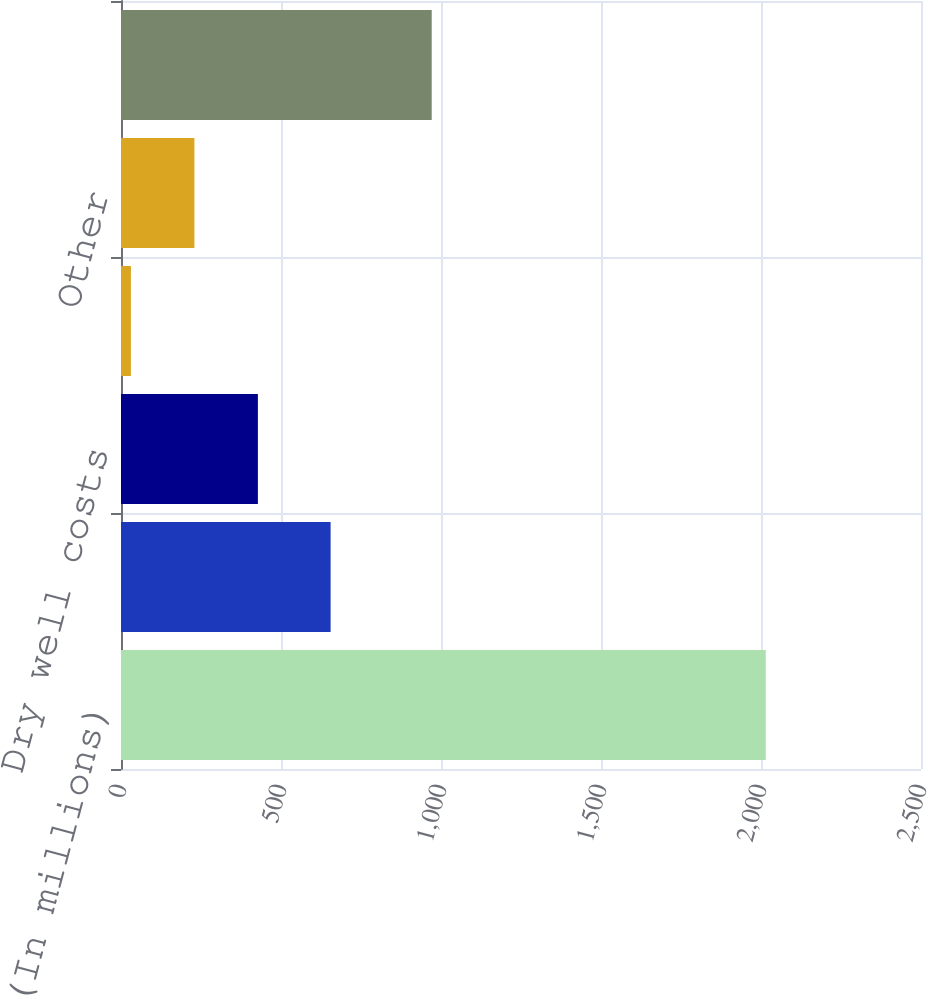<chart> <loc_0><loc_0><loc_500><loc_500><bar_chart><fcel>(In millions)<fcel>Unproved property impairments<fcel>Dry well costs<fcel>Geological and geophysical<fcel>Other<fcel>Total exploration expenses<nl><fcel>2015<fcel>655<fcel>427.8<fcel>31<fcel>229.4<fcel>971<nl></chart> 